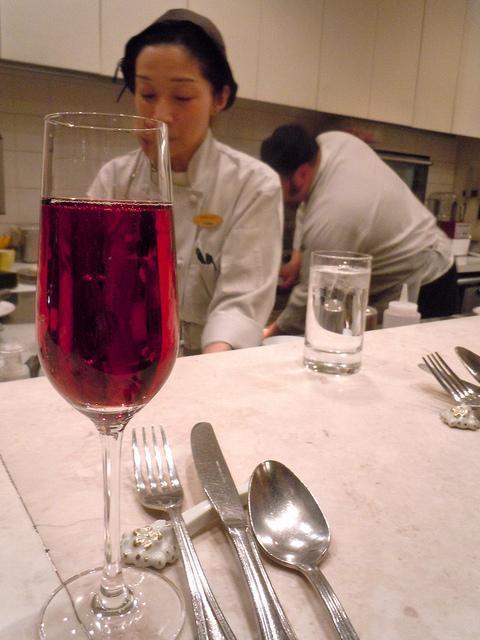How many glasses of wine are there?
Give a very brief answer. 1. How many glasses are there?
Give a very brief answer. 2. How many forks are there?
Give a very brief answer. 1. How many people are in the photo?
Give a very brief answer. 2. How many clocks are there?
Give a very brief answer. 0. 